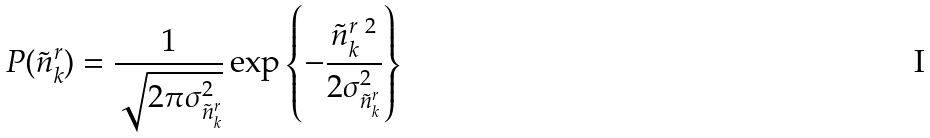<formula> <loc_0><loc_0><loc_500><loc_500>P ( \tilde { n } ^ { r } _ { k } ) = \frac { 1 } { \sqrt { 2 \pi \sigma ^ { 2 } _ { \tilde { n } ^ { r } _ { k } } } } \exp \left \{ - \frac { \tilde { n } ^ { r \ 2 } _ { k } } { 2 \sigma ^ { 2 } _ { \tilde { n } ^ { r } _ { k } } } \right \}</formula> 